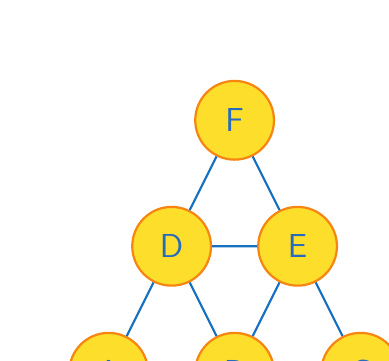Could you help me with this problem? To solve this problem, we'll use the concept of graph coloring from graph theory. Here's a step-by-step approach:

1) First, we need to understand what the graph represents:
   - Vertices (A, B, C, D, E, F) represent player positions on the field.
   - Edges represent potential passing lanes or close proximity between positions.

2) The goal is to color the graph such that no two adjacent vertices have the same color, using the minimum number of colors possible. This is known as the chromatic number of the graph.

3) Let's start coloring the graph:
   - Assign color 1 to vertex A.
   - B is adjacent to A, so it needs a different color. Assign color 2 to B.
   - C is adjacent to B but not A, so we can use color 1 for C.
   - D is adjacent to A and B, so it needs a new color. Assign color 3 to D.
   - E is adjacent to B, C, and D, so it needs a new color. Assign color 4 to E.
   - F is adjacent to D and E, so we can use color 1 or 2 for F. Let's use color 1.

4) We've used 4 colors in total, and it's impossible to color the graph with fewer colors due to the connections between B, D, and E.

5) In soccer terms, this means we need at least 4 different player types or roles to ensure versatility in the formation:
   - Color 1: Positions A, C, F (e.g., forwards)
   - Color 2: Position B (e.g., central midfielder)
   - Color 3: Position D (e.g., defensive midfielder)
   - Color 4: Position E (e.g., winger)

Therefore, the chromatic number of this graph is 4, meaning Pacific FC needs a minimum of 4 player types for an optimally versatile formation.
Answer: 4 